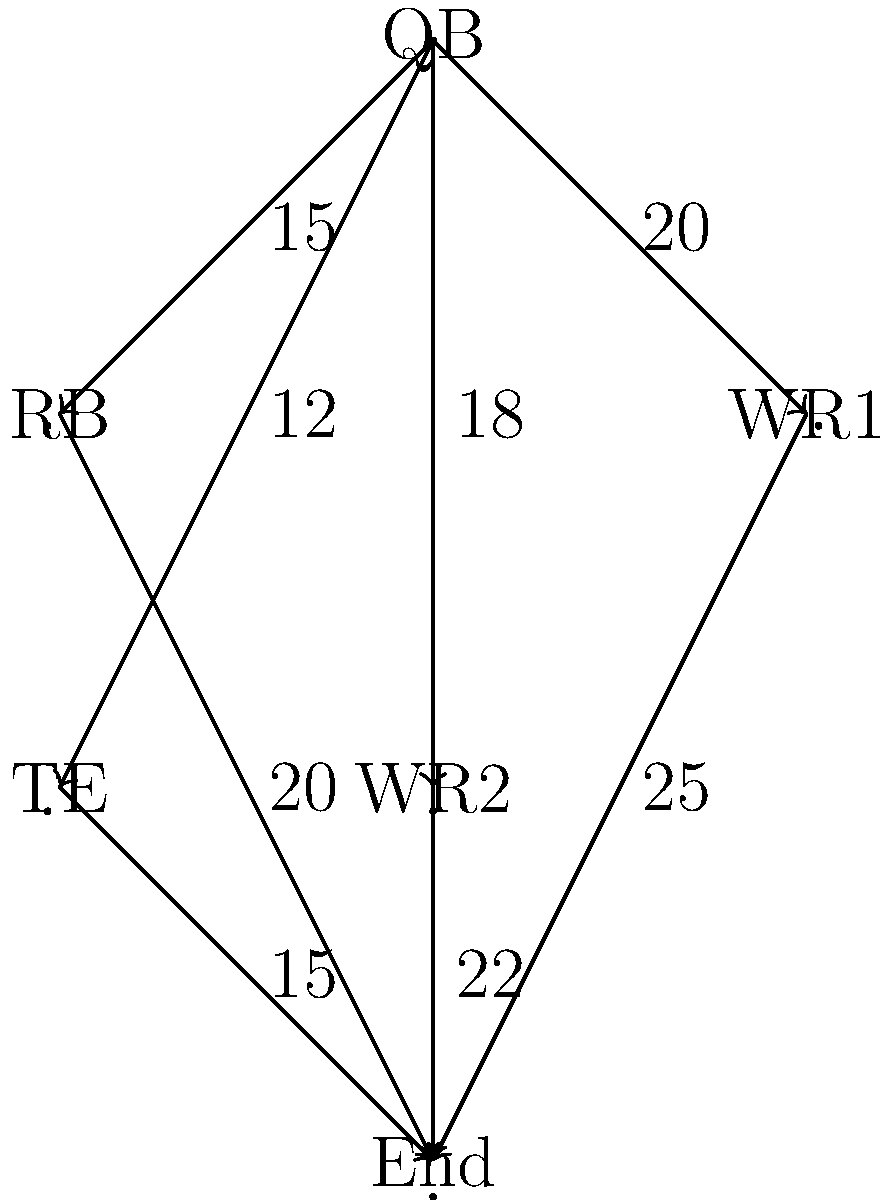In the offensive flow network shown above, where each edge represents the maximum number of points that can be scored through that connection per game, what is the maximum total points that can be scored per game using this offensive formation? To solve this problem, we need to find the maximum flow in the given network. We'll use the Ford-Fulkerson algorithm:

1. Identify source (QB) and sink (End) nodes.

2. Find augmenting paths and their capacities:
   Path 1: QB -> WR1 -> End (min capacity: 20)
   Path 2: QB -> WR2 -> End (min capacity: 18)
   Path 3: QB -> RB -> End (min capacity: 15)
   Path 4: QB -> TE -> End (min capacity: 12)

3. Sum the capacities of all augmenting paths:
   $20 + 18 + 15 + 12 = 65$

4. Verify that this is the maximum flow:
   - The total outflow from QB is $15 + 20 + 18 + 12 = 65$
   - The total inflow to End is $20 + 25 + 22 + 15 = 82$
   - The minimum of these two is 65, which matches our calculated flow

Therefore, the maximum total points that can be scored per game using this offensive formation is 65.
Answer: 65 points 